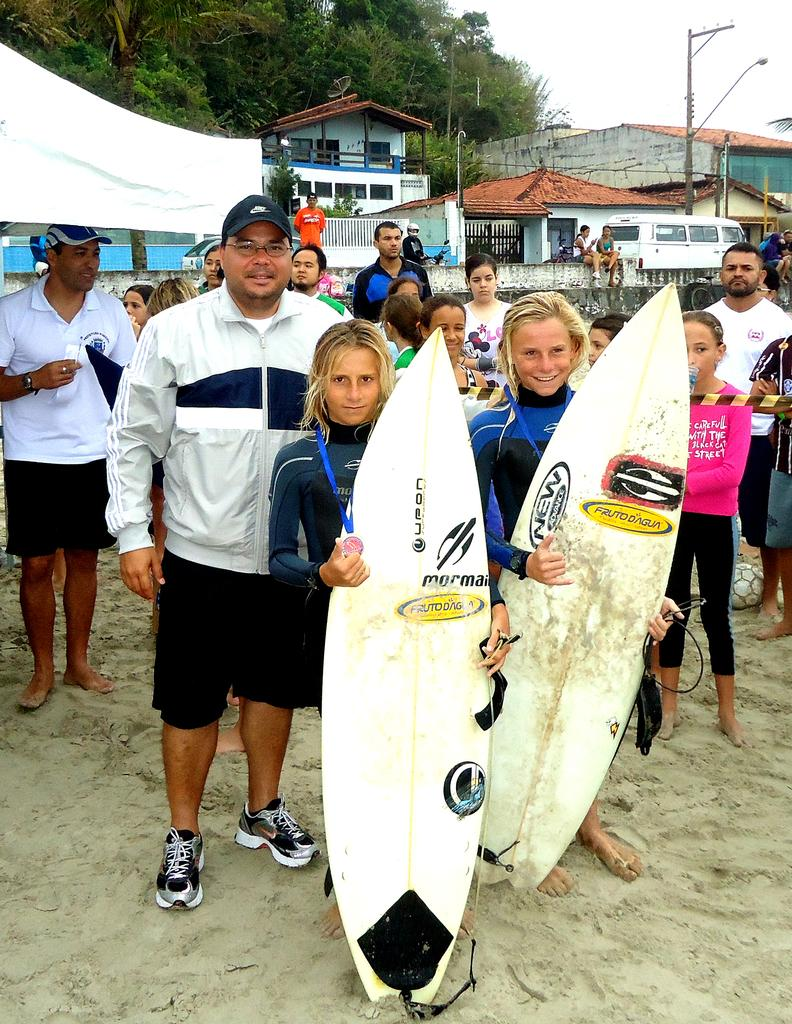How many ladies are in the image? There are two ladies in the image. What are the ladies holding in the image? The ladies are holding surfing boards. What type of structures can be seen in the image? There are houses in the image. Can you describe any other objects or vehicles in the image? A vehicle is visible in the image. What type of natural elements can be seen in the image? There are trees in the image. Are there any other people besides the two ladies in the image? Yes, there are people in the image. What song is being sung by the trees in the image? There are no trees singing in the image; they are simply trees. How can you measure the height of the bed in the image? There is no bed present in the image. 